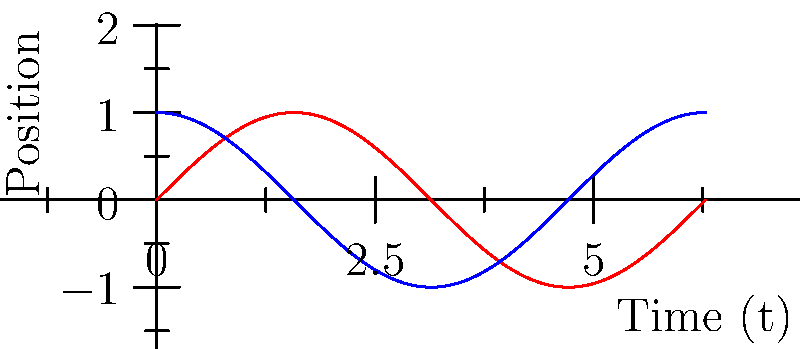In a virtual reality environment, you need to create smooth, natural-looking animations for AI-controlled characters. You decide to use trigonometric functions to model the character's walking motion. Given that the character's vertical position $y$ is modeled by $y = A \sin(\omega t)$ and its horizontal position $x$ is modeled by $x = B \cos(\omega t)$, where $A$ and $B$ are amplitudes, $\omega$ is the angular frequency, and $t$ is time, what is the phase difference between the vertical and horizontal motions? Let's approach this step-by-step:

1) The vertical position is given by $y = A \sin(\omega t)$
2) The horizontal position is given by $x = B \cos(\omega t)$

3) To find the phase difference, we need to compare these two functions:
   - $\sin(\omega t)$ represents the vertical motion
   - $\cos(\omega t)$ represents the horizontal motion

4) Recall the trigonometric identity: $\cos(x) = \sin(x + \frac{\pi}{2})$

5) This means that cosine is essentially a sine function shifted by $\frac{\pi}{2}$ radians or 90 degrees.

6) In our case, the horizontal motion (cosine) leads the vertical motion (sine) by $\frac{\pi}{2}$ radians.

7) Therefore, the phase difference between the vertical and horizontal motions is $\frac{\pi}{2}$ radians or 90 degrees.

This phase difference creates a circular or elliptical path (depending on A and B values), which can be used to model smooth, cyclic motions like walking or running in AI-controlled characters.
Answer: $\frac{\pi}{2}$ radians or 90 degrees 